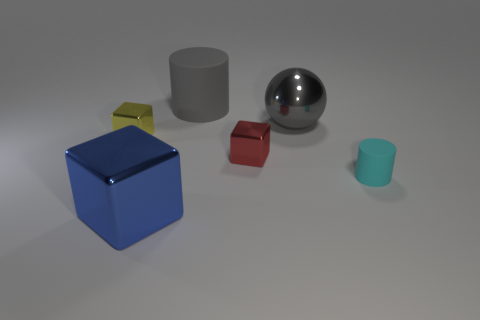Add 4 cyan shiny objects. How many objects exist? 10 Subtract all cylinders. How many objects are left? 4 Subtract all tiny red metal blocks. Subtract all small gray matte cylinders. How many objects are left? 5 Add 1 gray cylinders. How many gray cylinders are left? 2 Add 3 small blue matte cubes. How many small blue matte cubes exist? 3 Subtract 1 blue cubes. How many objects are left? 5 